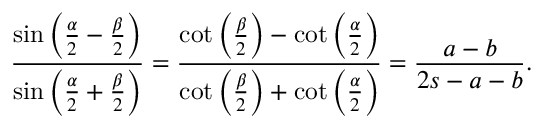<formula> <loc_0><loc_0><loc_500><loc_500>{ \frac { \sin \left ( { \frac { \alpha } { 2 } } - { \frac { \beta } { 2 } } \right ) } { \sin \left ( { \frac { \alpha } { 2 } } + { \frac { \beta } { 2 } } \right ) } } = { \frac { \cot \left ( { \frac { \beta } { 2 } } \right ) - \cot \left ( { \frac { \alpha } { 2 } } \right ) } { \cot \left ( { \frac { \beta } { 2 } } \right ) + \cot \left ( { \frac { \alpha } { 2 } } \right ) } } = { \frac { a - b } { 2 s - a - b } } .</formula> 